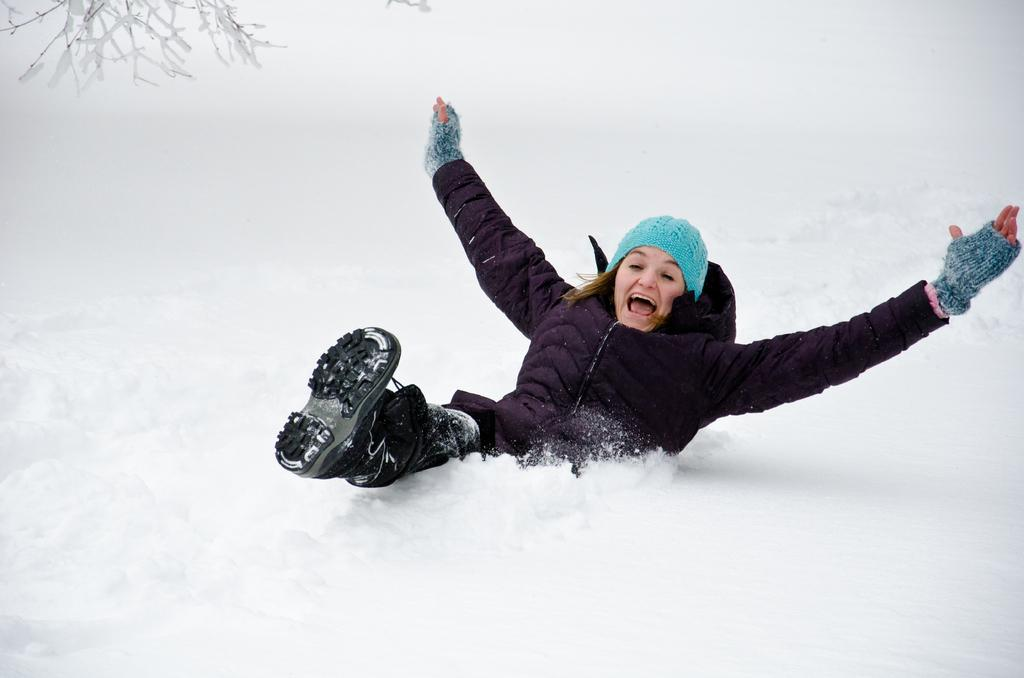Who is the main subject in the image? There is a woman in the image. What is the woman doing in the image? The woman is playing in the snow. Can you describe the background of the image? There are leaves visible at the top left of the image. What type of wine is the woman holding in the image? There is no wine present in the image; the woman is playing in the snow. 